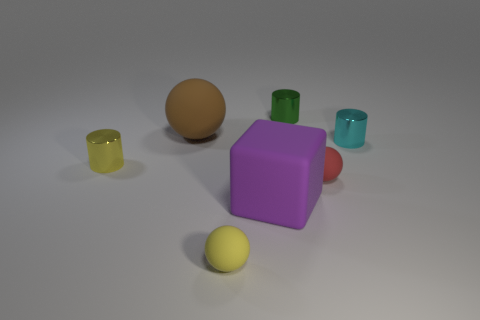There is a rubber sphere behind the tiny yellow cylinder; what size is it?
Keep it short and to the point. Large. What material is the large brown thing?
Provide a succinct answer. Rubber. What is the shape of the big rubber object that is behind the yellow thing on the left side of the large brown sphere?
Keep it short and to the point. Sphere. How many other things are there of the same shape as the red rubber thing?
Provide a succinct answer. 2. Are there any matte balls left of the large purple block?
Provide a short and direct response. Yes. What color is the big matte cube?
Provide a short and direct response. Purple. Are there any cyan cylinders that have the same size as the red ball?
Your answer should be very brief. Yes. What is the material of the small object behind the tiny cyan thing?
Ensure brevity in your answer.  Metal. Are there an equal number of large objects in front of the large purple rubber cube and small yellow balls to the right of the small yellow shiny thing?
Ensure brevity in your answer.  No. There is a object behind the brown ball; does it have the same size as the rubber sphere on the right side of the small yellow ball?
Offer a terse response. Yes. 